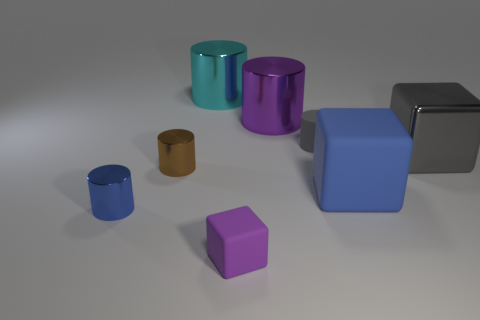Subtract all gray cylinders. How many cylinders are left? 4 Subtract all small matte cylinders. How many cylinders are left? 4 Subtract all purple cylinders. Subtract all yellow balls. How many cylinders are left? 4 Add 1 big cyan cubes. How many objects exist? 9 Subtract all cylinders. How many objects are left? 3 Subtract all objects. Subtract all small cyan matte things. How many objects are left? 0 Add 4 small blue cylinders. How many small blue cylinders are left? 5 Add 6 tiny blue cylinders. How many tiny blue cylinders exist? 7 Subtract 0 green balls. How many objects are left? 8 